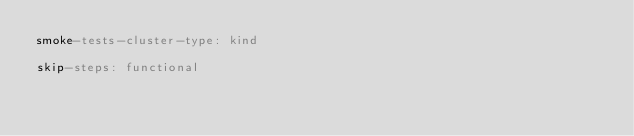Convert code to text. <code><loc_0><loc_0><loc_500><loc_500><_YAML_>smoke-tests-cluster-type: kind

skip-steps: functional
</code> 